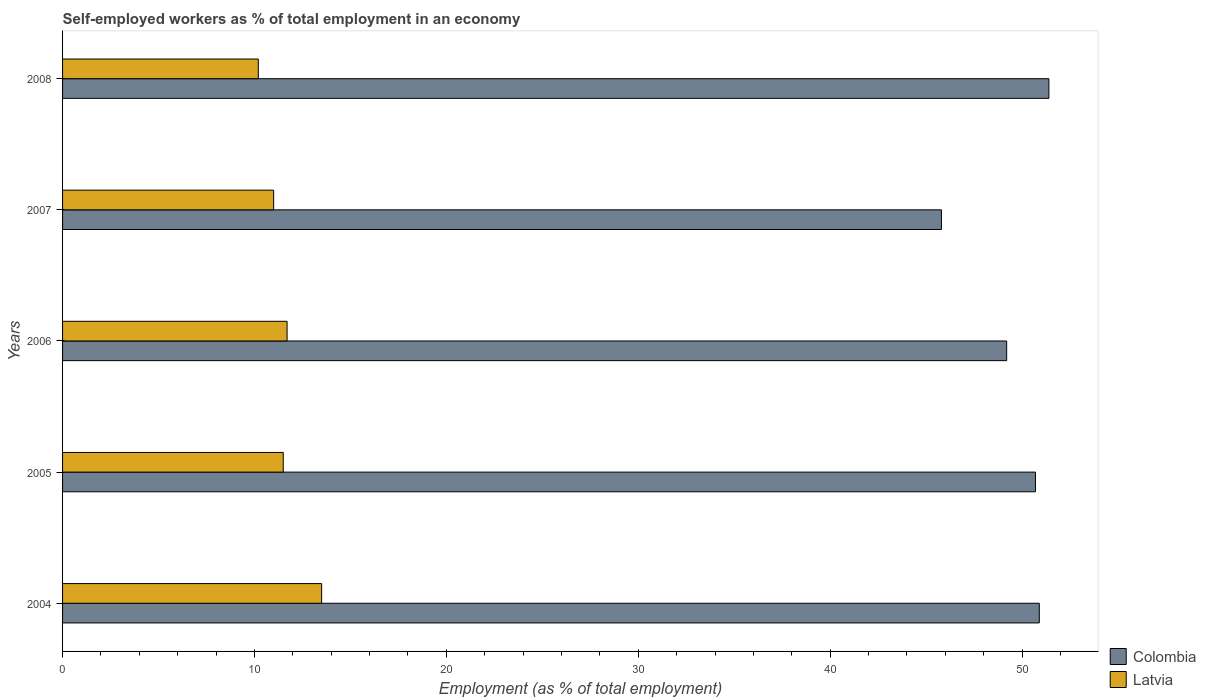How many groups of bars are there?
Keep it short and to the point. 5. Are the number of bars per tick equal to the number of legend labels?
Give a very brief answer. Yes. Are the number of bars on each tick of the Y-axis equal?
Offer a terse response. Yes. In how many cases, is the number of bars for a given year not equal to the number of legend labels?
Provide a succinct answer. 0. Across all years, what is the maximum percentage of self-employed workers in Latvia?
Keep it short and to the point. 13.5. Across all years, what is the minimum percentage of self-employed workers in Colombia?
Give a very brief answer. 45.8. What is the total percentage of self-employed workers in Latvia in the graph?
Make the answer very short. 57.9. What is the difference between the percentage of self-employed workers in Colombia in 2004 and that in 2005?
Give a very brief answer. 0.2. What is the difference between the percentage of self-employed workers in Latvia in 2006 and the percentage of self-employed workers in Colombia in 2005?
Your response must be concise. -39. What is the average percentage of self-employed workers in Latvia per year?
Your answer should be very brief. 11.58. In the year 2004, what is the difference between the percentage of self-employed workers in Latvia and percentage of self-employed workers in Colombia?
Provide a succinct answer. -37.4. What is the ratio of the percentage of self-employed workers in Latvia in 2004 to that in 2006?
Your answer should be compact. 1.15. Is the percentage of self-employed workers in Colombia in 2005 less than that in 2006?
Your answer should be very brief. No. What is the difference between the highest and the second highest percentage of self-employed workers in Latvia?
Ensure brevity in your answer.  1.8. What is the difference between the highest and the lowest percentage of self-employed workers in Latvia?
Your answer should be compact. 3.3. What does the 2nd bar from the top in 2008 represents?
Keep it short and to the point. Colombia. What does the 1st bar from the bottom in 2005 represents?
Provide a short and direct response. Colombia. What is the difference between two consecutive major ticks on the X-axis?
Your answer should be compact. 10. Are the values on the major ticks of X-axis written in scientific E-notation?
Give a very brief answer. No. Does the graph contain any zero values?
Your response must be concise. No. Where does the legend appear in the graph?
Your response must be concise. Bottom right. How many legend labels are there?
Your answer should be very brief. 2. What is the title of the graph?
Your answer should be compact. Self-employed workers as % of total employment in an economy. What is the label or title of the X-axis?
Make the answer very short. Employment (as % of total employment). What is the Employment (as % of total employment) in Colombia in 2004?
Your answer should be very brief. 50.9. What is the Employment (as % of total employment) of Colombia in 2005?
Give a very brief answer. 50.7. What is the Employment (as % of total employment) in Latvia in 2005?
Ensure brevity in your answer.  11.5. What is the Employment (as % of total employment) in Colombia in 2006?
Provide a short and direct response. 49.2. What is the Employment (as % of total employment) of Latvia in 2006?
Make the answer very short. 11.7. What is the Employment (as % of total employment) of Colombia in 2007?
Give a very brief answer. 45.8. What is the Employment (as % of total employment) of Latvia in 2007?
Your answer should be compact. 11. What is the Employment (as % of total employment) in Colombia in 2008?
Offer a very short reply. 51.4. What is the Employment (as % of total employment) in Latvia in 2008?
Keep it short and to the point. 10.2. Across all years, what is the maximum Employment (as % of total employment) in Colombia?
Provide a succinct answer. 51.4. Across all years, what is the maximum Employment (as % of total employment) of Latvia?
Make the answer very short. 13.5. Across all years, what is the minimum Employment (as % of total employment) in Colombia?
Offer a terse response. 45.8. Across all years, what is the minimum Employment (as % of total employment) in Latvia?
Your answer should be very brief. 10.2. What is the total Employment (as % of total employment) in Colombia in the graph?
Your answer should be very brief. 248. What is the total Employment (as % of total employment) in Latvia in the graph?
Keep it short and to the point. 57.9. What is the difference between the Employment (as % of total employment) in Latvia in 2004 and that in 2005?
Your answer should be very brief. 2. What is the difference between the Employment (as % of total employment) in Colombia in 2004 and that in 2006?
Ensure brevity in your answer.  1.7. What is the difference between the Employment (as % of total employment) in Latvia in 2004 and that in 2006?
Your response must be concise. 1.8. What is the difference between the Employment (as % of total employment) of Colombia in 2005 and that in 2006?
Make the answer very short. 1.5. What is the difference between the Employment (as % of total employment) in Latvia in 2005 and that in 2006?
Keep it short and to the point. -0.2. What is the difference between the Employment (as % of total employment) in Colombia in 2005 and that in 2007?
Ensure brevity in your answer.  4.9. What is the difference between the Employment (as % of total employment) of Latvia in 2005 and that in 2007?
Your response must be concise. 0.5. What is the difference between the Employment (as % of total employment) in Colombia in 2005 and that in 2008?
Offer a terse response. -0.7. What is the difference between the Employment (as % of total employment) of Latvia in 2005 and that in 2008?
Your answer should be compact. 1.3. What is the difference between the Employment (as % of total employment) of Colombia in 2007 and that in 2008?
Your response must be concise. -5.6. What is the difference between the Employment (as % of total employment) of Colombia in 2004 and the Employment (as % of total employment) of Latvia in 2005?
Keep it short and to the point. 39.4. What is the difference between the Employment (as % of total employment) of Colombia in 2004 and the Employment (as % of total employment) of Latvia in 2006?
Provide a short and direct response. 39.2. What is the difference between the Employment (as % of total employment) of Colombia in 2004 and the Employment (as % of total employment) of Latvia in 2007?
Your answer should be very brief. 39.9. What is the difference between the Employment (as % of total employment) of Colombia in 2004 and the Employment (as % of total employment) of Latvia in 2008?
Your answer should be very brief. 40.7. What is the difference between the Employment (as % of total employment) of Colombia in 2005 and the Employment (as % of total employment) of Latvia in 2006?
Provide a short and direct response. 39. What is the difference between the Employment (as % of total employment) in Colombia in 2005 and the Employment (as % of total employment) in Latvia in 2007?
Provide a succinct answer. 39.7. What is the difference between the Employment (as % of total employment) in Colombia in 2005 and the Employment (as % of total employment) in Latvia in 2008?
Your response must be concise. 40.5. What is the difference between the Employment (as % of total employment) of Colombia in 2006 and the Employment (as % of total employment) of Latvia in 2007?
Ensure brevity in your answer.  38.2. What is the difference between the Employment (as % of total employment) in Colombia in 2006 and the Employment (as % of total employment) in Latvia in 2008?
Offer a terse response. 39. What is the difference between the Employment (as % of total employment) of Colombia in 2007 and the Employment (as % of total employment) of Latvia in 2008?
Give a very brief answer. 35.6. What is the average Employment (as % of total employment) of Colombia per year?
Provide a short and direct response. 49.6. What is the average Employment (as % of total employment) in Latvia per year?
Your response must be concise. 11.58. In the year 2004, what is the difference between the Employment (as % of total employment) in Colombia and Employment (as % of total employment) in Latvia?
Your answer should be compact. 37.4. In the year 2005, what is the difference between the Employment (as % of total employment) in Colombia and Employment (as % of total employment) in Latvia?
Provide a succinct answer. 39.2. In the year 2006, what is the difference between the Employment (as % of total employment) in Colombia and Employment (as % of total employment) in Latvia?
Provide a succinct answer. 37.5. In the year 2007, what is the difference between the Employment (as % of total employment) of Colombia and Employment (as % of total employment) of Latvia?
Keep it short and to the point. 34.8. In the year 2008, what is the difference between the Employment (as % of total employment) of Colombia and Employment (as % of total employment) of Latvia?
Make the answer very short. 41.2. What is the ratio of the Employment (as % of total employment) of Colombia in 2004 to that in 2005?
Your response must be concise. 1. What is the ratio of the Employment (as % of total employment) in Latvia in 2004 to that in 2005?
Your response must be concise. 1.17. What is the ratio of the Employment (as % of total employment) in Colombia in 2004 to that in 2006?
Provide a short and direct response. 1.03. What is the ratio of the Employment (as % of total employment) in Latvia in 2004 to that in 2006?
Your answer should be very brief. 1.15. What is the ratio of the Employment (as % of total employment) of Colombia in 2004 to that in 2007?
Your answer should be very brief. 1.11. What is the ratio of the Employment (as % of total employment) in Latvia in 2004 to that in 2007?
Offer a terse response. 1.23. What is the ratio of the Employment (as % of total employment) in Colombia in 2004 to that in 2008?
Provide a succinct answer. 0.99. What is the ratio of the Employment (as % of total employment) of Latvia in 2004 to that in 2008?
Keep it short and to the point. 1.32. What is the ratio of the Employment (as % of total employment) in Colombia in 2005 to that in 2006?
Your response must be concise. 1.03. What is the ratio of the Employment (as % of total employment) in Latvia in 2005 to that in 2006?
Give a very brief answer. 0.98. What is the ratio of the Employment (as % of total employment) in Colombia in 2005 to that in 2007?
Provide a short and direct response. 1.11. What is the ratio of the Employment (as % of total employment) of Latvia in 2005 to that in 2007?
Give a very brief answer. 1.05. What is the ratio of the Employment (as % of total employment) in Colombia in 2005 to that in 2008?
Provide a succinct answer. 0.99. What is the ratio of the Employment (as % of total employment) of Latvia in 2005 to that in 2008?
Provide a short and direct response. 1.13. What is the ratio of the Employment (as % of total employment) in Colombia in 2006 to that in 2007?
Provide a short and direct response. 1.07. What is the ratio of the Employment (as % of total employment) of Latvia in 2006 to that in 2007?
Ensure brevity in your answer.  1.06. What is the ratio of the Employment (as % of total employment) in Colombia in 2006 to that in 2008?
Make the answer very short. 0.96. What is the ratio of the Employment (as % of total employment) in Latvia in 2006 to that in 2008?
Offer a terse response. 1.15. What is the ratio of the Employment (as % of total employment) of Colombia in 2007 to that in 2008?
Offer a very short reply. 0.89. What is the ratio of the Employment (as % of total employment) in Latvia in 2007 to that in 2008?
Your response must be concise. 1.08. What is the difference between the highest and the second highest Employment (as % of total employment) in Latvia?
Make the answer very short. 1.8. What is the difference between the highest and the lowest Employment (as % of total employment) of Latvia?
Make the answer very short. 3.3. 